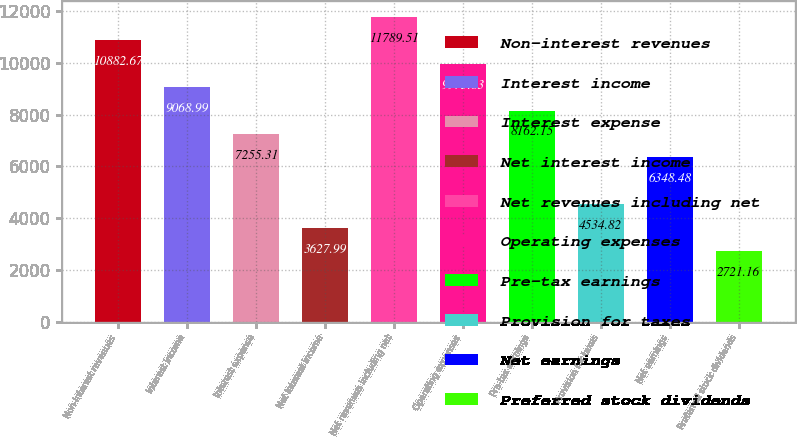<chart> <loc_0><loc_0><loc_500><loc_500><bar_chart><fcel>Non-interest revenues<fcel>Interest income<fcel>Interest expense<fcel>Net interest income<fcel>Net revenues including net<fcel>Operating expenses<fcel>Pre-tax earnings<fcel>Provision for taxes<fcel>Net earnings<fcel>Preferred stock dividends<nl><fcel>10882.7<fcel>9068.99<fcel>7255.31<fcel>3627.99<fcel>11789.5<fcel>9975.83<fcel>8162.15<fcel>4534.82<fcel>6348.48<fcel>2721.16<nl></chart> 